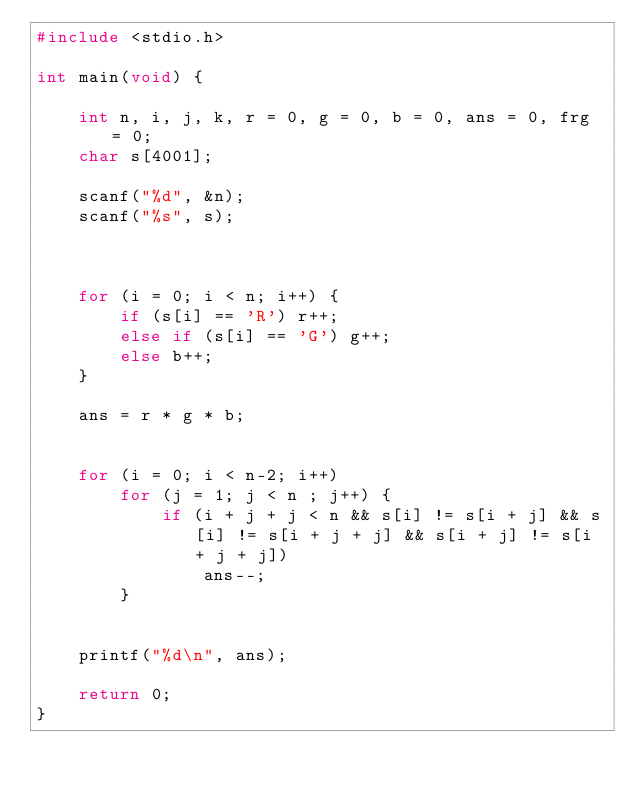Convert code to text. <code><loc_0><loc_0><loc_500><loc_500><_C_>#include <stdio.h>

int main(void) {

	int n, i, j, k, r = 0, g = 0, b = 0, ans = 0, frg = 0;
	char s[4001];

	scanf("%d", &n);
	scanf("%s", s);



	for (i = 0; i < n; i++) {
		if (s[i] == 'R') r++;
		else if (s[i] == 'G') g++;
		else b++;
	}

	ans = r * g * b;

	
	for (i = 0; i < n-2; i++)
		for (j = 1; j < n ; j++) {
			if (i + j + j < n && s[i] != s[i + j] && s[i] != s[i + j + j] && s[i + j] != s[i + j + j])
				ans--;
		}

			
	printf("%d\n", ans);

	return 0;
}</code> 